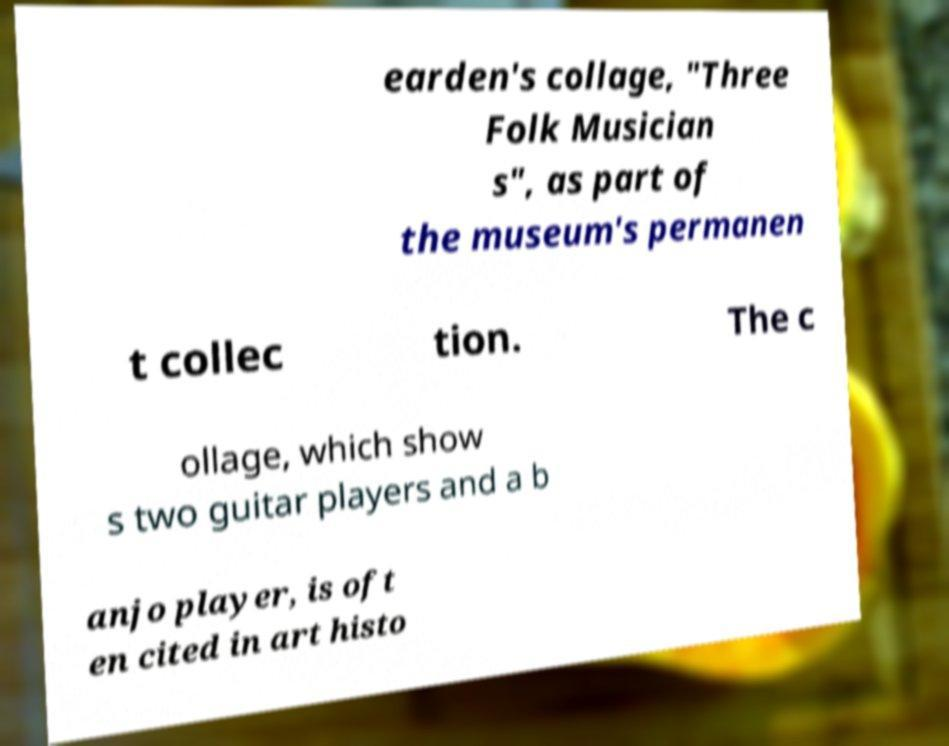Please read and relay the text visible in this image. What does it say? earden's collage, "Three Folk Musician s", as part of the museum's permanen t collec tion. The c ollage, which show s two guitar players and a b anjo player, is oft en cited in art histo 